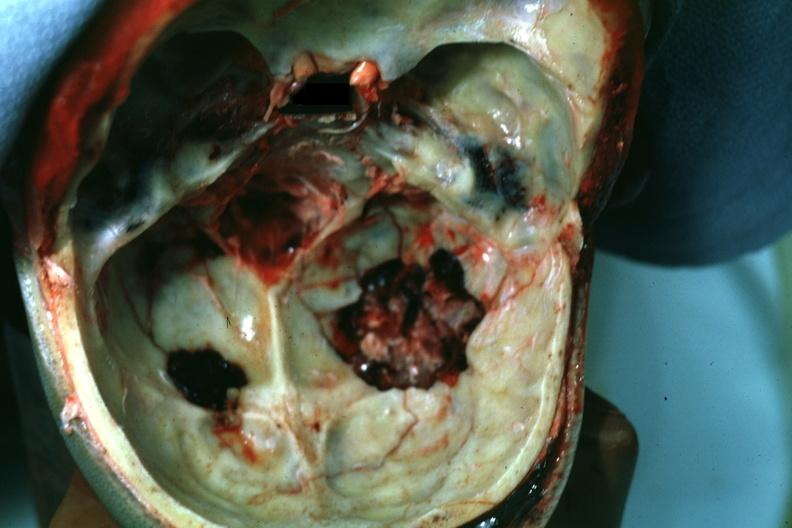s slide present?
Answer the question using a single word or phrase. No 